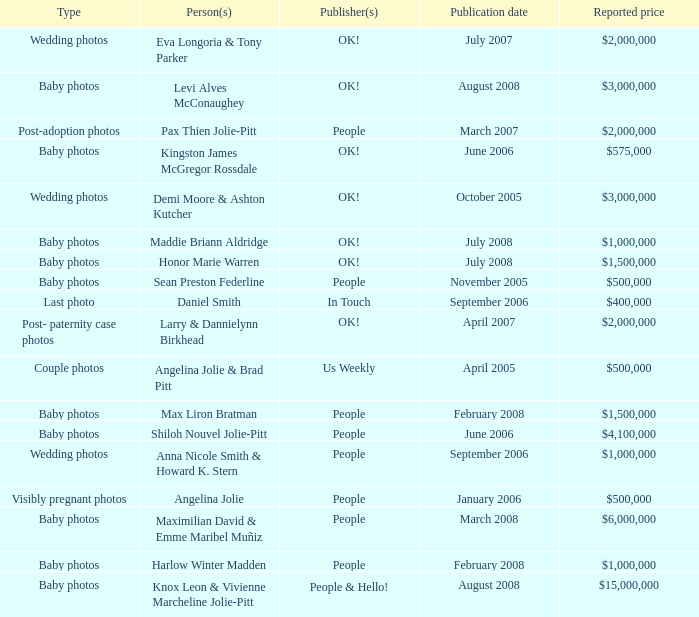What type of photos of Angelina Jolie cost $500,000? Visibly pregnant photos. 